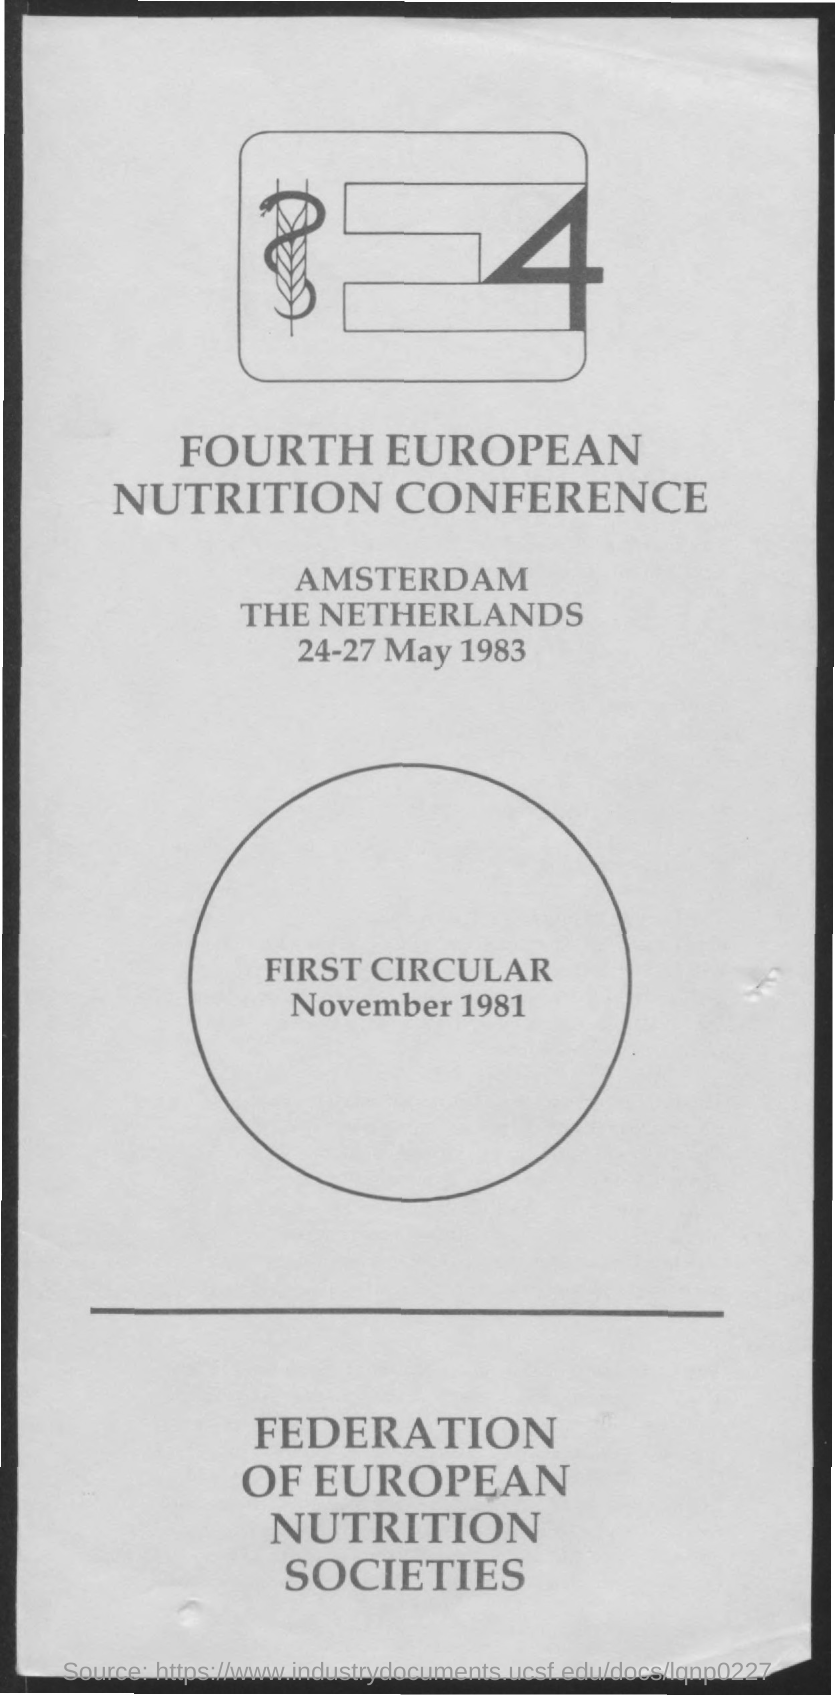Specify some key components in this picture. The Fourth European Nutrition Conference was held from May 24th to May 27th, 1983. 